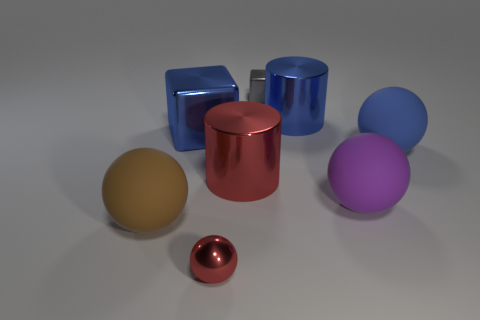How many other things are there of the same material as the big brown object?
Offer a very short reply. 2. Do the big cylinder that is in front of the blue matte sphere and the big brown thing have the same material?
Your answer should be compact. No. There is a gray block that is behind the metal object in front of the big matte sphere left of the tiny gray shiny object; how big is it?
Ensure brevity in your answer.  Small. How many other things are the same color as the tiny metallic block?
Provide a succinct answer. 0. What shape is the red object that is the same size as the brown object?
Make the answer very short. Cylinder. There is a metallic block on the left side of the red cylinder; what is its size?
Provide a succinct answer. Large. Does the tiny metal thing that is in front of the tiny gray shiny thing have the same color as the block that is to the left of the metallic sphere?
Offer a terse response. No. The tiny object that is behind the tiny thing in front of the small metal thing that is behind the purple sphere is made of what material?
Offer a terse response. Metal. Are there any metal blocks of the same size as the blue matte object?
Give a very brief answer. Yes. What is the material of the sphere that is the same size as the gray metallic cube?
Offer a terse response. Metal. 